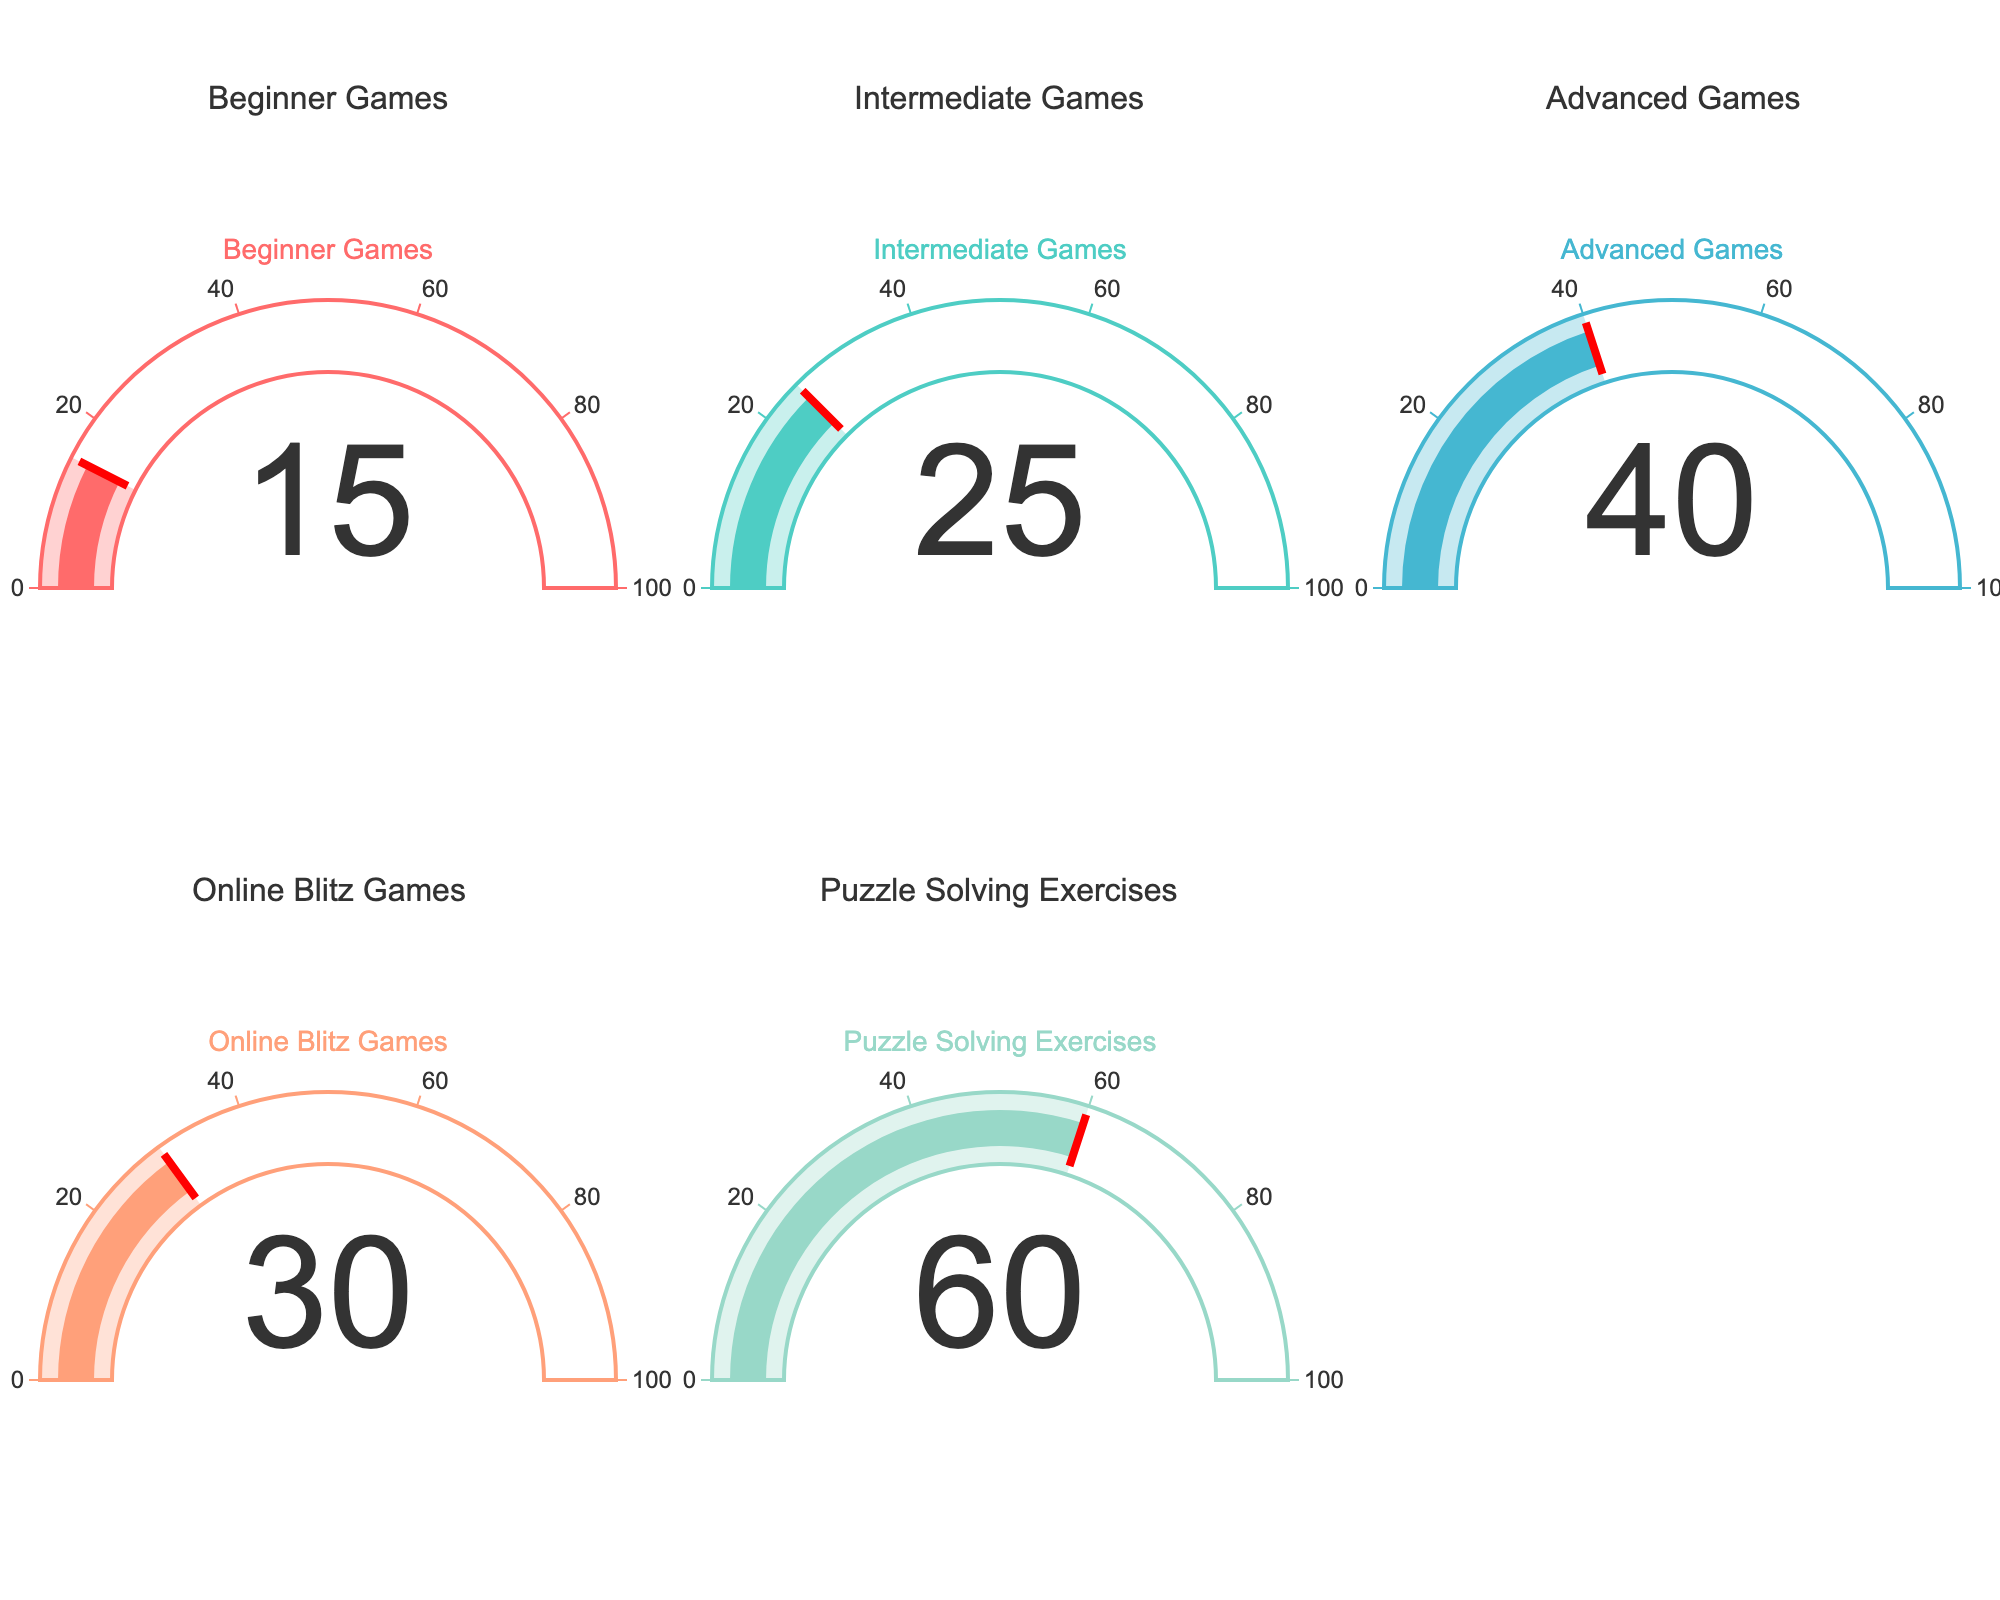What is the proportion of Beginner Games ending in checkmate? The gauge chart for Beginner Games shows a proportion of 15%, which is directly visible from the figure.
Answer: 15% What category has the highest proportion of games ending in checkmate? By inspecting the gauge charts, Puzzle Solving Exercises has the highest proportion with a value of 60%.
Answer: Puzzle Solving Exercises Is the proportion of Intermediate Games ending in checkmate higher than that of Online Blitz Games? The gauge chart for Intermediate Games shows a value of 25%, and for Online Blitz Games, it shows 30%. Since 25% is less than 30%, Intermediate Games has a lower proportion.
Answer: No Which two categories have nearly the same proportions of games ending in checkmate? By comparing the gauge charts, Intermediate Games (25%) and Online Blitz Games (30%) have values that are fairly close.
Answer: Intermediate Games and Online Blitz Games What's the average proportion of games ending in checkmate across all the categories shown in the figure? The values from the gauge charts are 15%, 25%, 40%, 30%, and 60%. Summing these proportions gives 15% + 25% + 40% + 30% + 60% = 170%. The average is then 170% / 5 = 34%.
Answer: 34% How much higher is the proportion of Advanced Games ending in checkmate compared to Beginner Games? From the gauge charts, Advanced Games is 40% and Beginner Games is 15%. The difference is 40% - 15% = 25%.
Answer: 25% Which category has the lowest proportion of games ending in checkmate? By examining the gauge charts, Beginner Games shows the lowest value of 15%.
Answer: Beginner Games Combine the proportions of Intermediate and Advanced Games ending in checkmate. How much is it? The gauge charts for Intermediate Games and Advanced Games show 25% and 40%, respectively. Their combined proportion is 25% + 40% = 65%.
Answer: 65% What's the difference between the highest and lowest proportions of games ending in checkmate? The highest proportion is 60% for Puzzle Solving Exercises and the lowest is 15% for Beginner Games. The difference is 60% - 15% = 45%.
Answer: 45% 